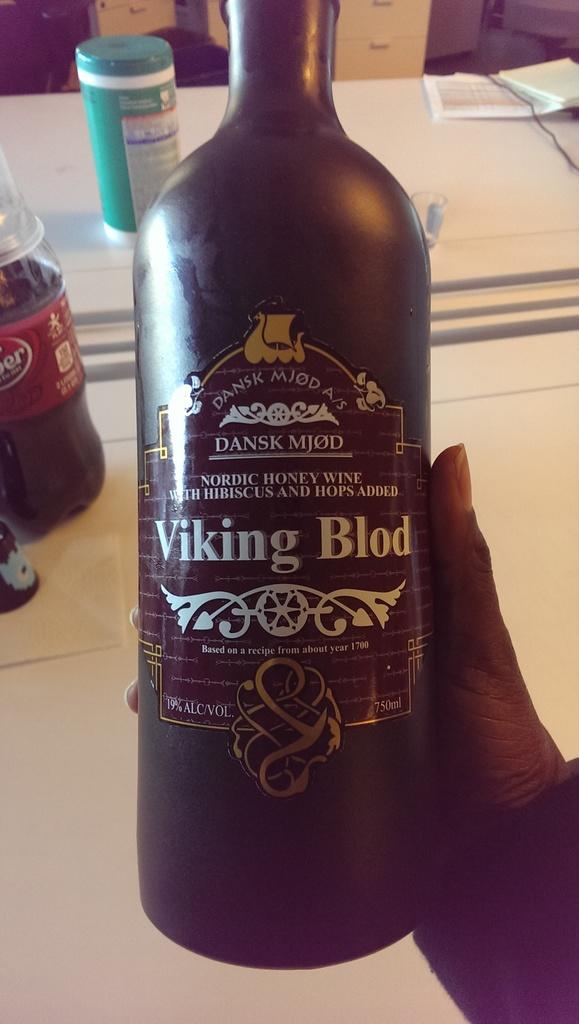What is the name of this wine?
Make the answer very short. Viking blod. What is the alc. vol.?
Offer a very short reply. 19%. 